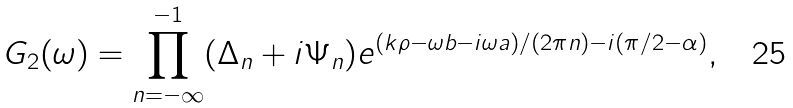<formula> <loc_0><loc_0><loc_500><loc_500>G _ { 2 } ( \omega ) = \prod _ { n = - \infty } ^ { - 1 } ( \Delta _ { n } + i \Psi _ { n } ) e ^ { ( k \rho - \omega b - i \omega a ) / ( 2 \pi n ) - i ( \pi / 2 - \alpha ) } ,</formula> 